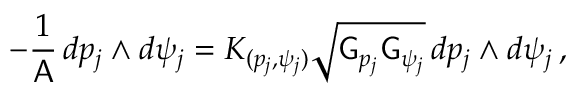<formula> <loc_0><loc_0><loc_500><loc_500>- \frac { 1 } { A } \, d p _ { j } \wedge d \psi _ { j } = K _ { ( p _ { j } , \psi _ { j } ) } \sqrt { G _ { p _ { j } } G _ { \psi _ { j } } } \, d p _ { j } \wedge d \psi _ { j } \, ,</formula> 